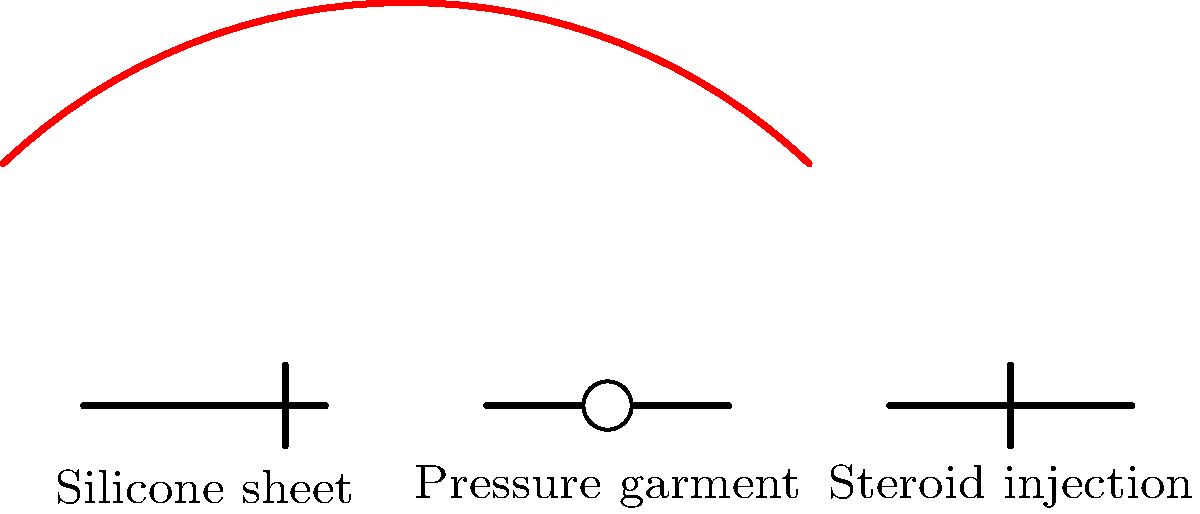Which of the illustrated scar management techniques is most effective for reducing hypertrophic scars and keloids, especially in the early stages of scar formation? To answer this question, let's analyze each of the illustrated scar management techniques:

1. Silicone sheets: These are often used for scar management and have been shown to be effective in reducing hypertrophic scars and preventing keloid formation. They work by creating a moist environment and providing gentle pressure to the scar area.

2. Pressure garments: These are commonly used for larger areas of scarring, such as those resulting from burns. They apply constant pressure to the scar, which can help flatten and soften it over time.

3. Steroid injections: These are typically used for stubborn hypertrophic scars and keloids that haven't responded well to other treatments. They work by reducing inflammation and inhibiting collagen production.

Among these options, silicone sheets are generally considered the most effective and safest option for early scar management, especially for hypertrophic scars and keloids. Here's why:

1. Non-invasive: Unlike steroid injections, silicone sheets don't require any needles or injections, making them safer and more comfortable for patients.

2. Suitable for early use: Silicone sheets can be applied as soon as the wound has healed, making them ideal for early intervention.

3. Proven efficacy: Numerous studies have shown the effectiveness of silicone in reducing scar formation and improving the appearance of existing scars.

4. Ease of use: Patients can easily apply and remove silicone sheets at home, making them convenient for long-term use.

5. Fewer side effects: Compared to steroid injections, which can cause skin thinning and discoloration, silicone sheets have minimal side effects.

While pressure garments can be effective for large areas of scarring, they are less commonly used for isolated hypertrophic scars or keloids. Steroid injections, while effective, are typically reserved for cases where other treatments have failed due to their potential side effects and the need for medical administration.
Answer: Silicone sheets 